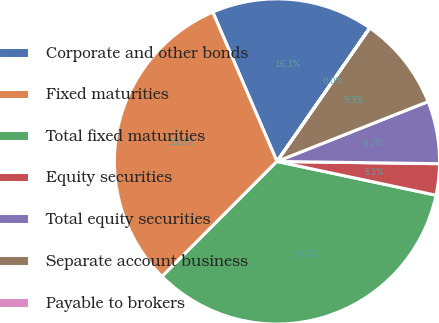Convert chart to OTSL. <chart><loc_0><loc_0><loc_500><loc_500><pie_chart><fcel>Corporate and other bonds<fcel>Fixed maturities<fcel>Total fixed maturities<fcel>Equity securities<fcel>Total equity securities<fcel>Separate account business<fcel>Payable to brokers<nl><fcel>16.12%<fcel>31.05%<fcel>34.16%<fcel>3.11%<fcel>6.22%<fcel>9.33%<fcel>0.01%<nl></chart> 